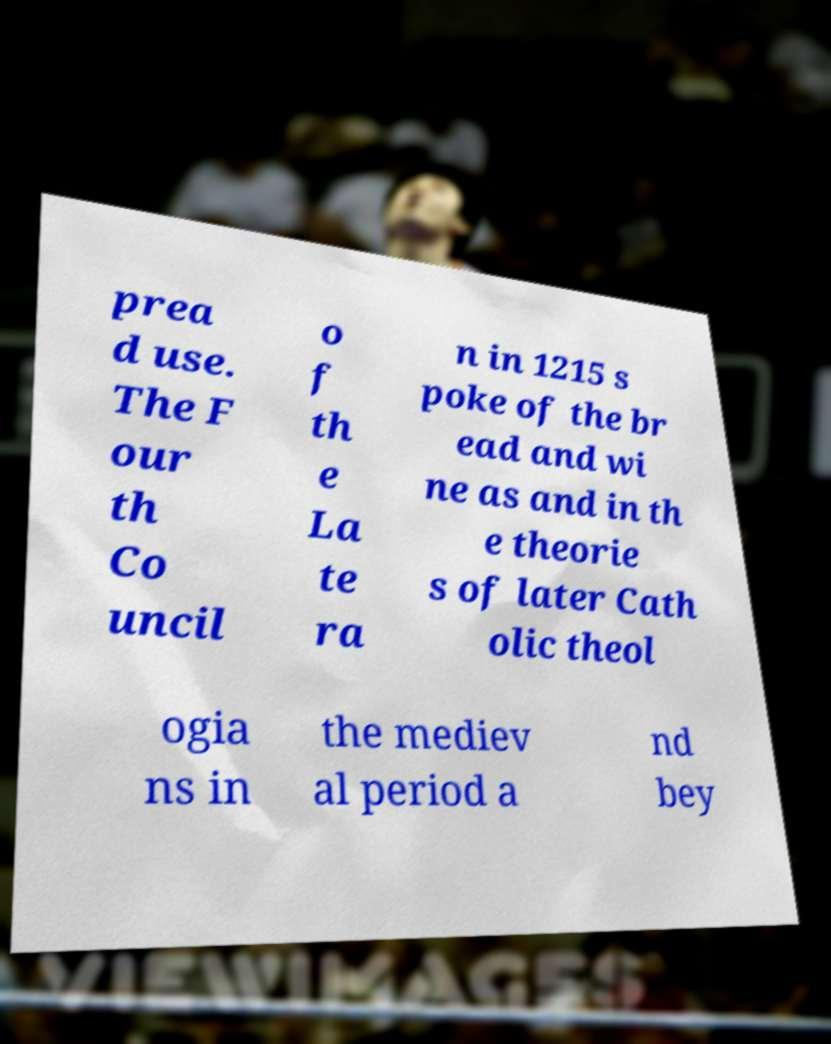For documentation purposes, I need the text within this image transcribed. Could you provide that? prea d use. The F our th Co uncil o f th e La te ra n in 1215 s poke of the br ead and wi ne as and in th e theorie s of later Cath olic theol ogia ns in the mediev al period a nd bey 